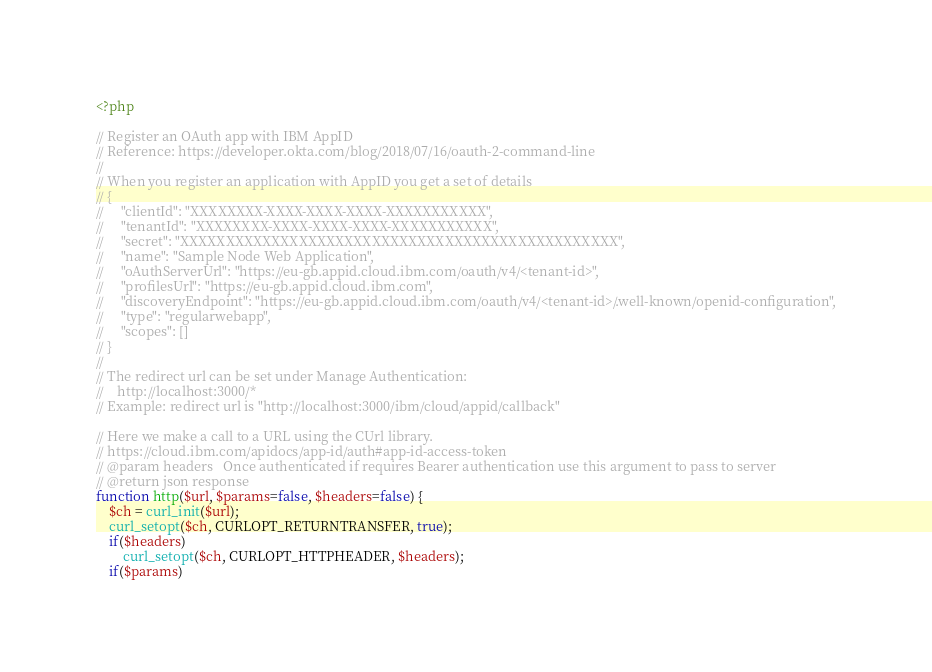<code> <loc_0><loc_0><loc_500><loc_500><_PHP_><?php

// Register an OAuth app with IBM AppID
// Reference: https://developer.okta.com/blog/2018/07/16/oauth-2-command-line
//
// When you register an application with AppID you get a set of details
// {
//     "clientId": "XXXXXXXX-XXXX-XXXX-XXXX-XXXXXXXXXXX",
//     "tenantId": "XXXXXXXX-XXXX-XXXX-XXXX-XXXXXXXXXXX",
//     "secret": "XXXXXXXXXXXXXXXXXXXXXXXXXXXXXXXXXXXXXXXXXXXXXXXX",
//     "name": "Sample Node Web Application",
//     "oAuthServerUrl": "https://eu-gb.appid.cloud.ibm.com/oauth/v4/<tenant-id>",
//     "profilesUrl": "https://eu-gb.appid.cloud.ibm.com",
//     "discoveryEndpoint": "https://eu-gb.appid.cloud.ibm.com/oauth/v4/<tenant-id>/.well-known/openid-configuration",
//     "type": "regularwebapp",
//     "scopes": []
// }
//
// The redirect url can be set under Manage Authentication:
//    http://localhost:3000/*
// Example: redirect url is "http://localhost:3000/ibm/cloud/appid/callback"

// Here we make a call to a URL using the CUrl library.
// https://cloud.ibm.com/apidocs/app-id/auth#app-id-access-token
// @param headers   Once authenticated if requires Bearer authentication use this argument to pass to server
// @return json response
function http($url, $params=false, $headers=false) {
    $ch = curl_init($url);
    curl_setopt($ch, CURLOPT_RETURNTRANSFER, true);
    if($headers) 
        curl_setopt($ch, CURLOPT_HTTPHEADER, $headers);
    if($params)</code> 